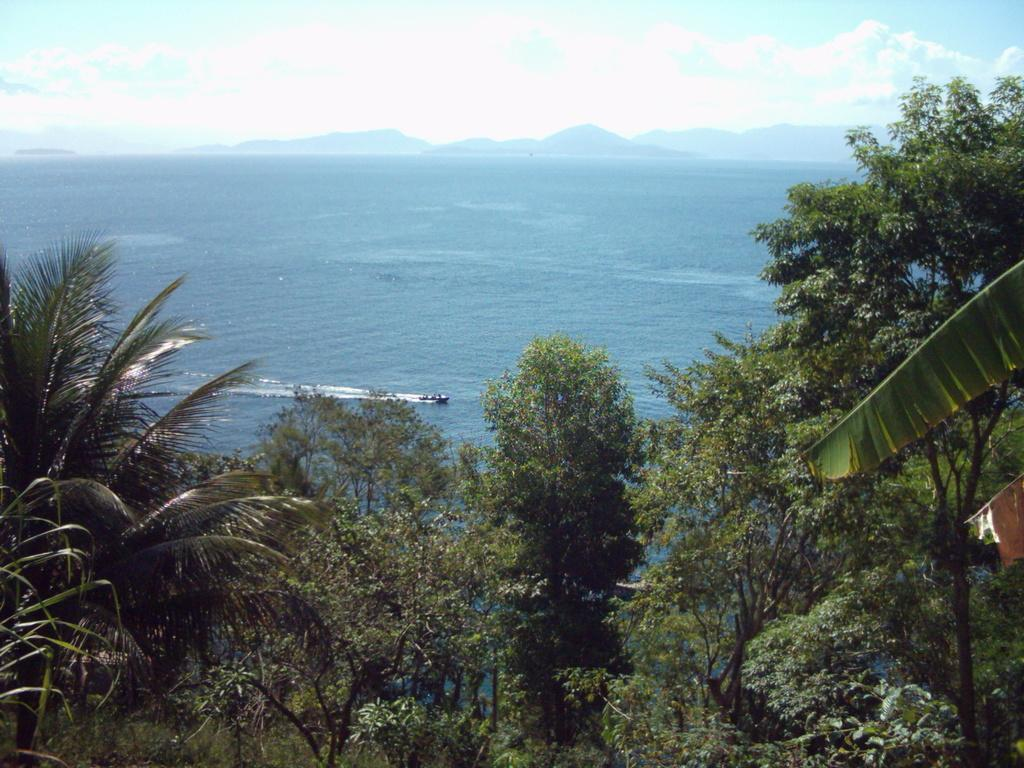What type of vegetation can be seen in the image? There are plants and trees visible in the image. What is the water in the image? There is an object in the water, but it is not clear what it is. What type of terrain is visible in the image? There are hills visible in the image. What is visible in the sky in the image? The sky is visible in the image, and there are clouds present. Can you see any fingers in the image? There are no fingers visible in the image. What type of pest is present in the image? There is no pest present in the image. 